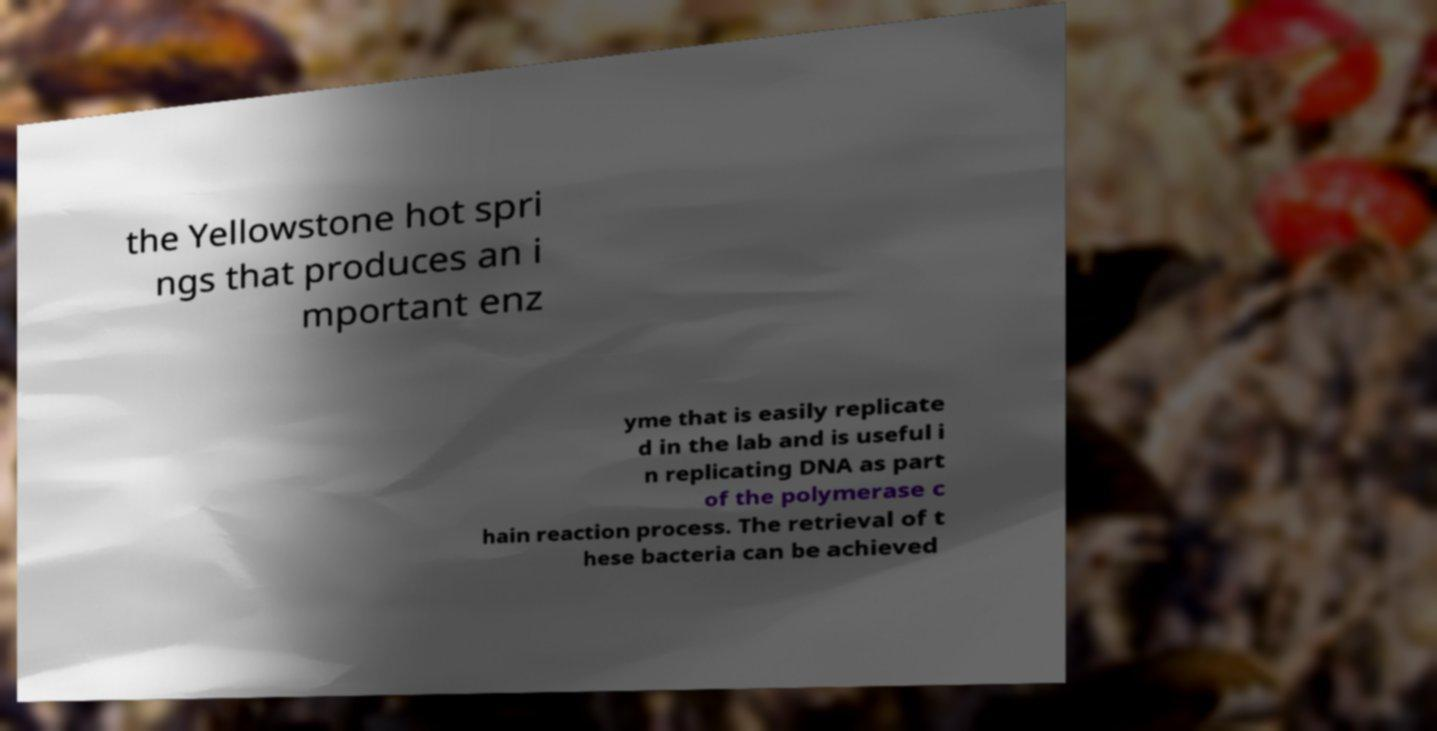Can you accurately transcribe the text from the provided image for me? the Yellowstone hot spri ngs that produces an i mportant enz yme that is easily replicate d in the lab and is useful i n replicating DNA as part of the polymerase c hain reaction process. The retrieval of t hese bacteria can be achieved 